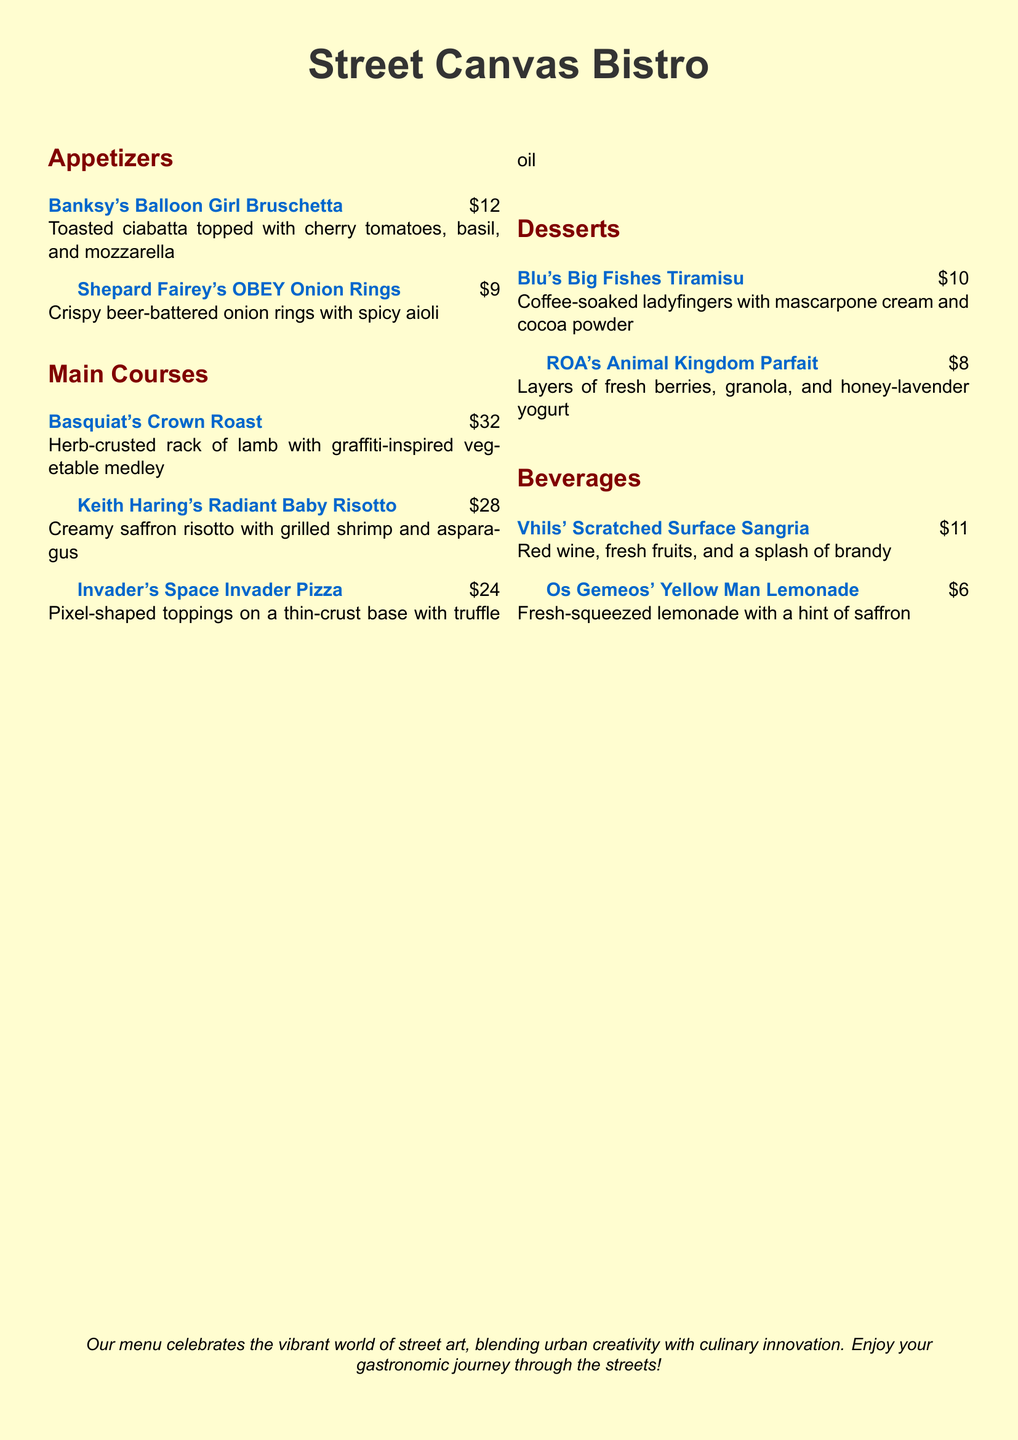what is the name of the restaurant? The name of the restaurant is prominently displayed at the top of the menu and is "Street Canvas Bistro."
Answer: Street Canvas Bistro how much does the OBEY Onion Rings cost? The cost of the OBEY Onion Rings is listed under the appetizers section alongside the item name.
Answer: $9 which dessert is inspired by Blu? The dessert inspired by Blu is mentioned in the dessert section of the menu.
Answer: Blu's Big Fishes Tiramisu what type of beverage is Vhils' Scratched Surface Sangria? The type of beverage is specified next to its name on the menu.
Answer: Sangria how many main courses are listed on the menu? By counting the entries under the main courses section, we can determine the total number.
Answer: 3 which artist is associated with the Crown Roast dish? The dish name indicates which famous street artist it is named after, found in the main courses section.
Answer: Basquiat what is included in Keith Haring's Radiant Baby Risotto? The ingredients for the Radiant Baby Risotto are detailed in the description of the dish.
Answer: Grilled shrimp and asparagus what is the price of the Yellow Man Lemonade? The price of the Yellow Man Lemonade is shown next to the beverage listing.
Answer: $6 which two desserts have fruit in them? This requires reviewing both dessert descriptions to find those that mention fruit.
Answer: Blu's Big Fishes Tiramisu, ROA's Animal Kingdom Parfait 